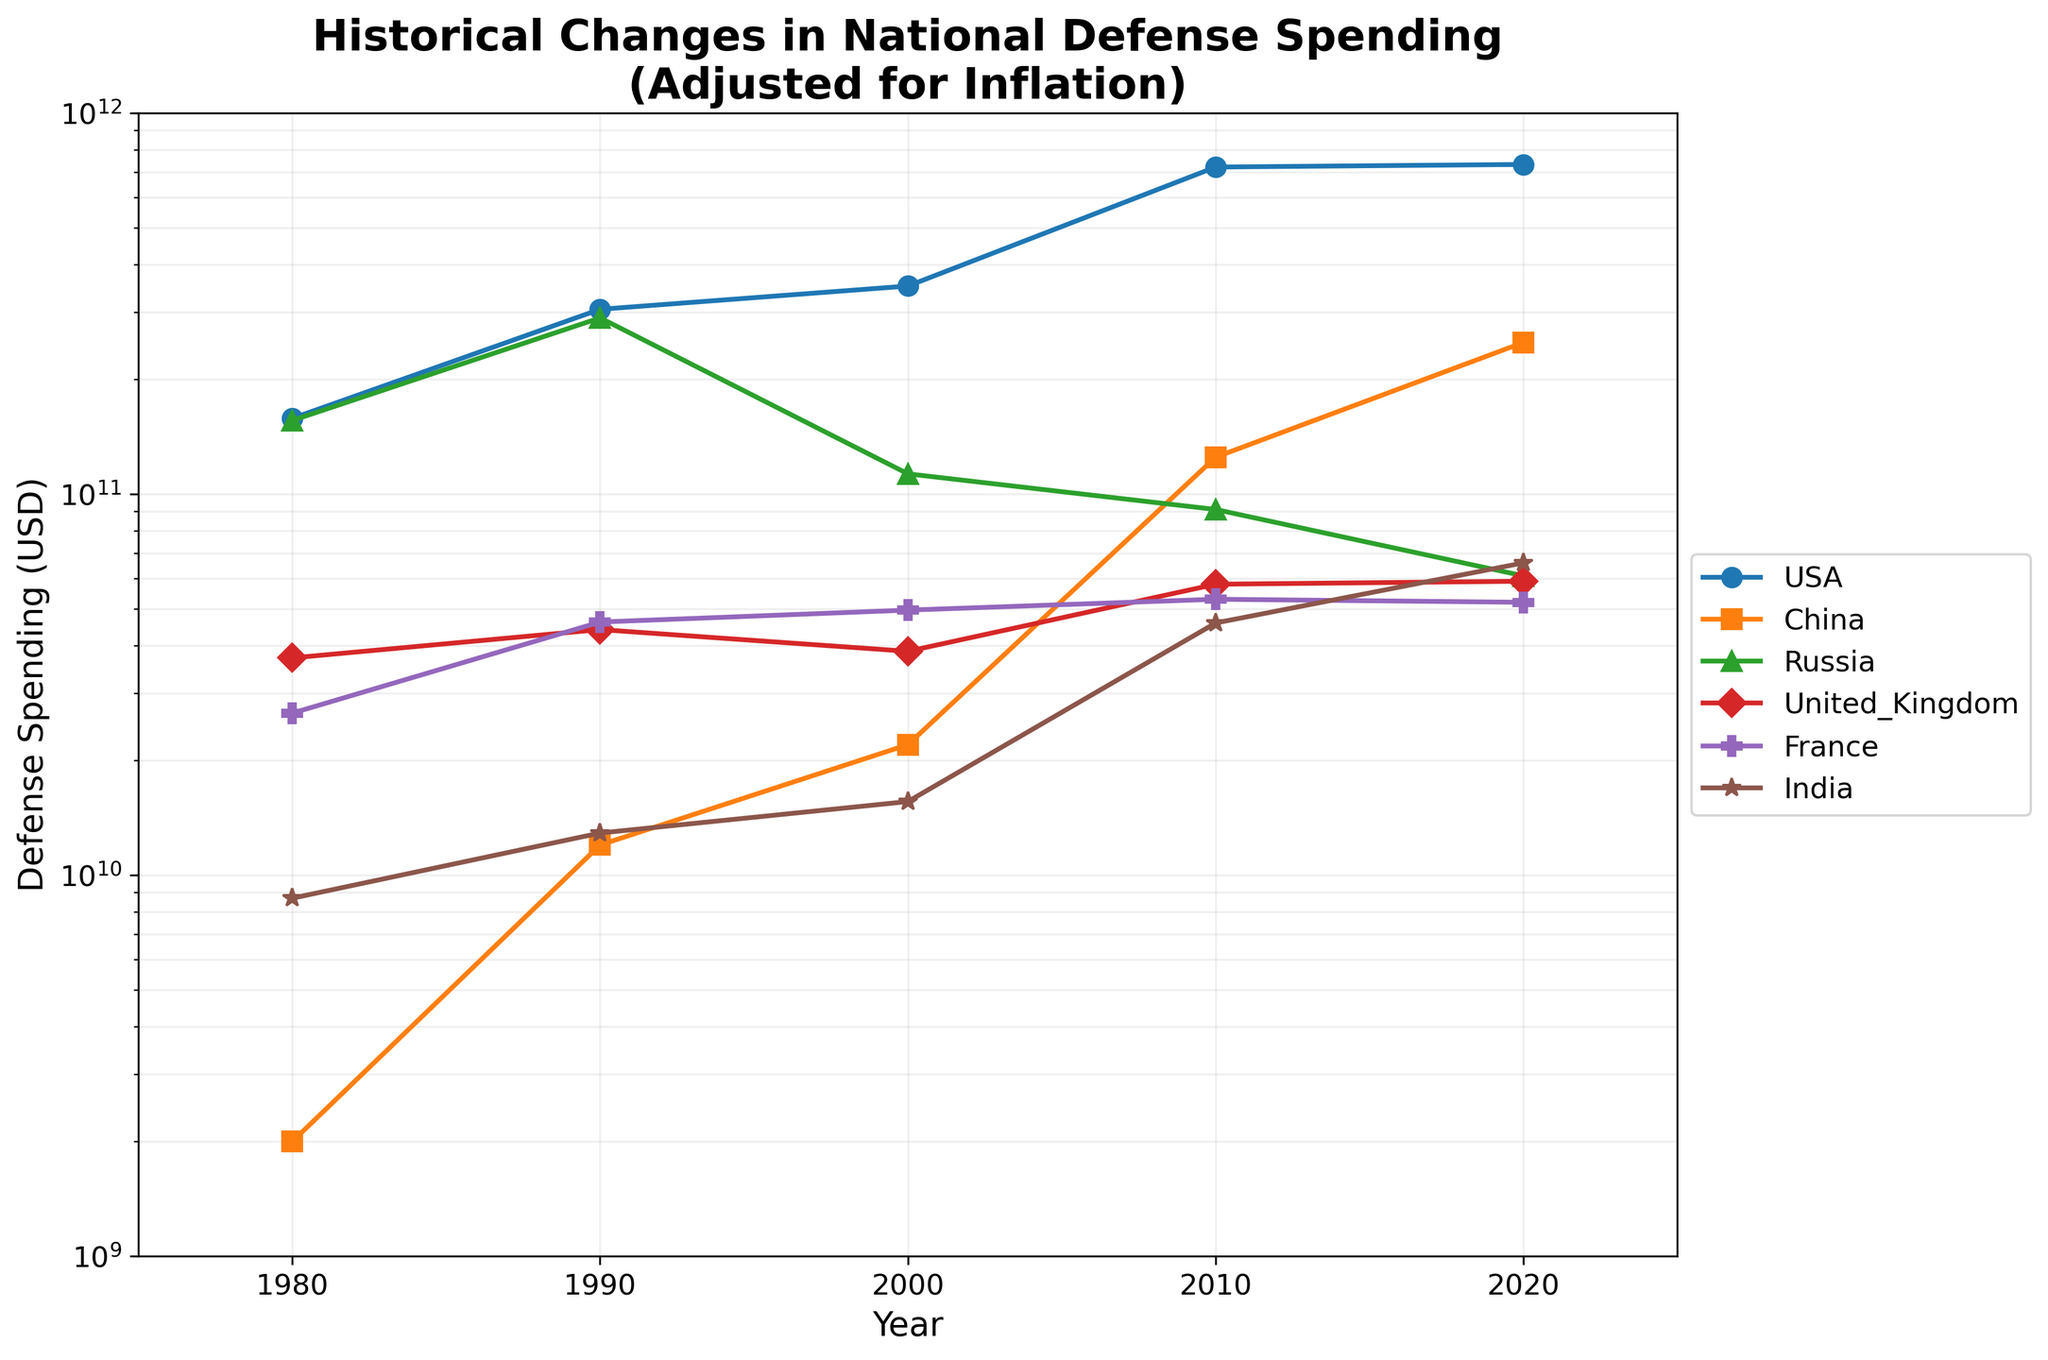what is the title of the plot? To identify the title, look at the top center of the plot where titles are typically placed.
Answer: Historical Changes in National Defense Spending (Adjusted for Inflation) How many countries are represented in the plot? Count the number of unique country lines plotted, each with a distinct color and marker.
Answer: 6 Which country had the highest defense spending in 1980? Locate the year 1980 on the x-axis, and find the y-value (defense spending) for each country. The country with the highest y-value is the answer.
Answer: USA In which year did the USA have the highest defense spending? Look for the highest y-value (defense spending) of the USA line, and identify the corresponding year on the x-axis.
Answer: 2010 Which countries had an increase in defense spending between 2000 and 2020? Compare the y-values of each country at the years 2000 and 2020, and identify the countries where the y-value increased.
Answer: China, India What was the approximate defense spending of Russia in 1990? Locate the year 1990 on the x-axis, and find the y-value for Russia at this point.
Answer: 290 billion USD Which country shows the steepest increase in defense spending from 1980 to 2020? Evaluate the slope of the line for each country between 1980 and 2020; the country with the steepest slope has the steepest increase.
Answer: China How does the defense spending of France in 2020 compare to 1980? Locate France's y-values for the years 1980 and 2020 on the plot, and compare them directly.
Answer: Similar Which two countries have the closest defense spending in 2020? Compare the y-values of all countries for the year 2020, and find the two countries with the smallest difference between their values.
Answer: Russia and France 